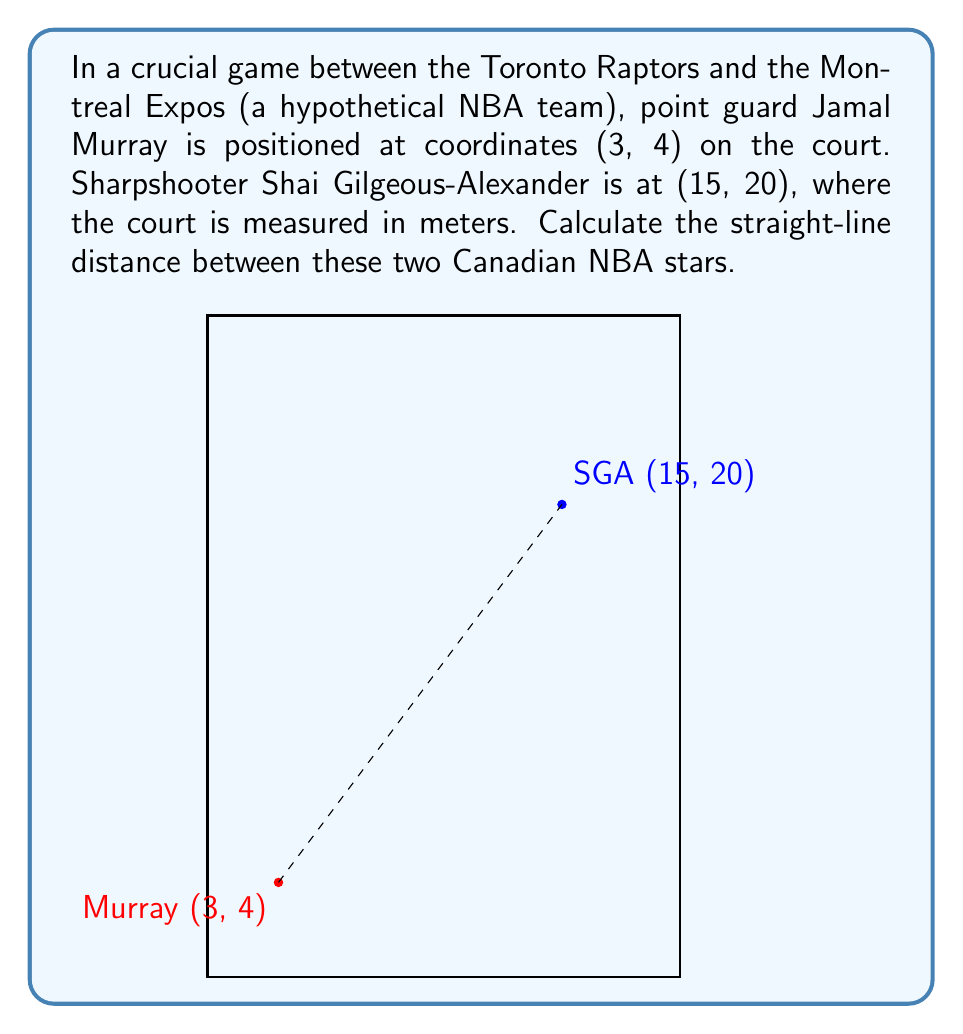Teach me how to tackle this problem. To find the distance between two points on a coordinate plane, we can use the distance formula, which is derived from the Pythagorean theorem:

$$d = \sqrt{(x_2 - x_1)^2 + (y_2 - y_1)^2}$$

Where $(x_1, y_1)$ is the position of the first point and $(x_2, y_2)$ is the position of the second point.

Let's plug in our values:
$(x_1, y_1) = (3, 4)$ for Jamal Murray
$(x_2, y_2) = (15, 20)$ for Shai Gilgeous-Alexander

Now, let's calculate:

$$\begin{align}
d &= \sqrt{(15 - 3)^2 + (20 - 4)^2} \\
&= \sqrt{12^2 + 16^2} \\
&= \sqrt{144 + 256} \\
&= \sqrt{400} \\
&= 20
\end{align}$$

Therefore, the distance between Jamal Murray and Shai Gilgeous-Alexander on the court is 20 meters.
Answer: 20 meters 